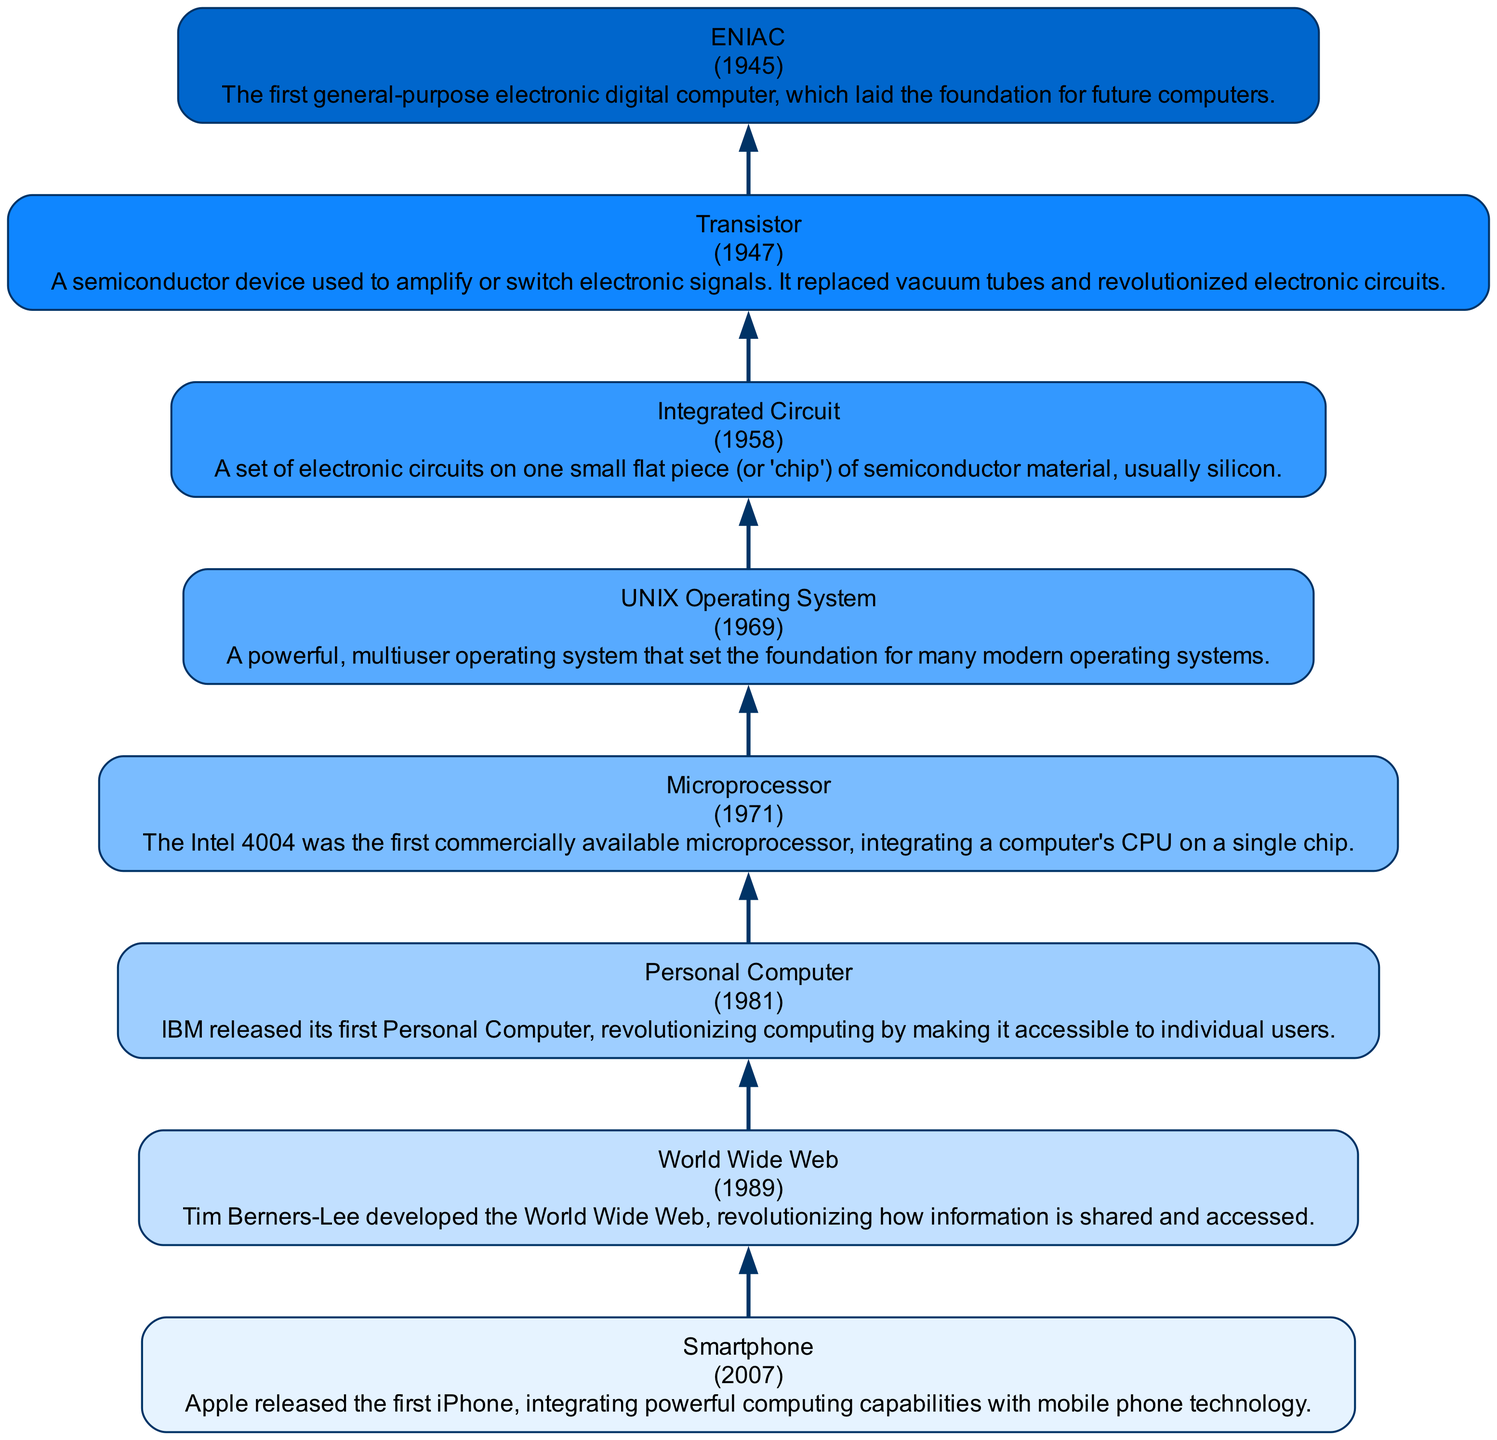What is the first milestone listed in the diagram? The first milestone listed in the diagram, which is at the bottom, is ENIAC from the year 1945.
Answer: ENIAC Which year did the Integrated Circuit milestone occur? The Integrated Circuit is listed directly above ENIAC in the diagram, marked with the year 1958.
Answer: 1958 How many key milestones are shown in the diagram? By counting each node in the diagram, there are a total of eight milestones from ENIAC to the Smartphone.
Answer: 8 What device replaced vacuum tubes as shown in the diagram? The Transistor, listed right after the ENIAC in the diagram, is described as replacing vacuum tubes.
Answer: Transistor Which milestone describes the development of a multiuser operating system? The UNIX Operating System milestone, found higher up in the flow, is identified as setting the foundation for many modern operating systems.
Answer: UNIX Operating System What is the last milestone mentioned in the diagram? The last milestone at the top of the diagram is the Smartphone from 2007, which marks modern mobile computing's integration.
Answer: Smartphone Which milestone directly precedes the Personal Computer in the diagram? The Microprocessor, mentioned right before the Personal Computer, highlights its role in integrating CPU functions on a chip.
Answer: Microprocessor Which milestone is associated with Tim Berners-Lee? The World Wide Web, marked in the diagram, is associated with Tim Berners-Lee and is vital for information sharing.
Answer: World Wide Web What is the common theme among the milestones listed in the diagram? The diagram highlights significant advancements in computer hardware and software which collectively shaped modern computing technology.
Answer: Computer hardware development 